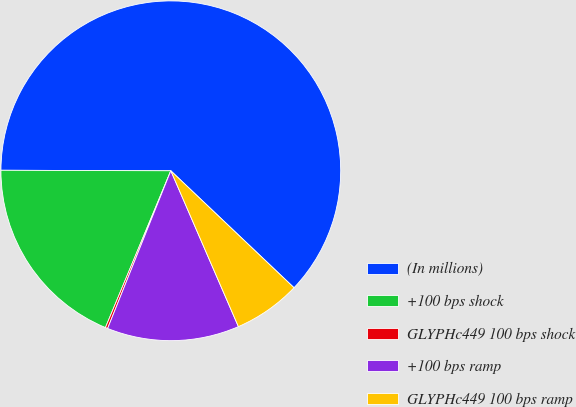Convert chart to OTSL. <chart><loc_0><loc_0><loc_500><loc_500><pie_chart><fcel>(In millions)<fcel>+100 bps shock<fcel>GLYPHc449 100 bps shock<fcel>+100 bps ramp<fcel>GLYPHc449 100 bps ramp<nl><fcel>62.04%<fcel>18.76%<fcel>0.22%<fcel>12.58%<fcel>6.4%<nl></chart> 